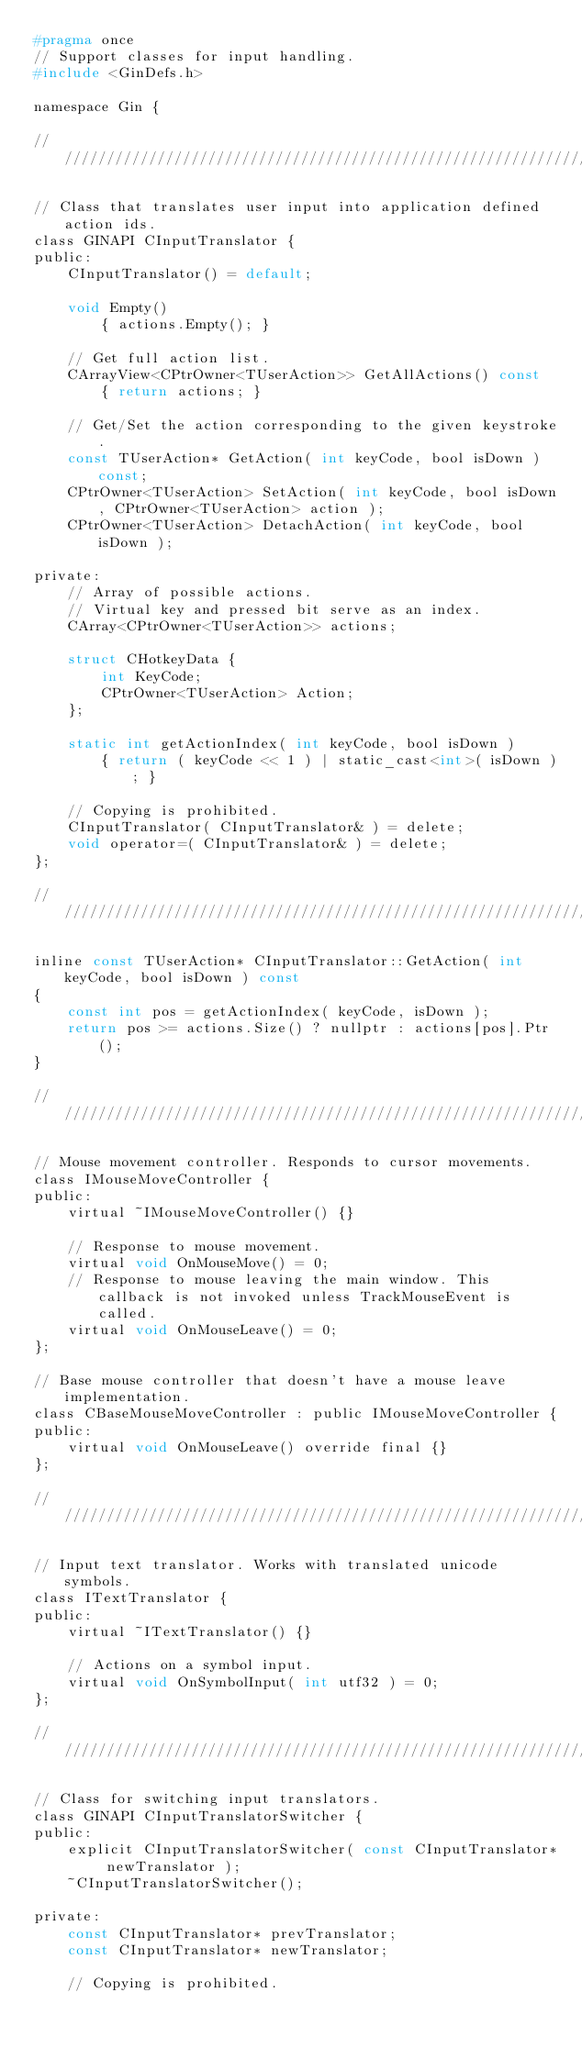Convert code to text. <code><loc_0><loc_0><loc_500><loc_500><_C_>#pragma once
// Support classes for input handling.
#include <GinDefs.h>

namespace Gin {

//////////////////////////////////////////////////////////////////////////

// Class that translates user input into application defined action ids.
class GINAPI CInputTranslator {
public:
	CInputTranslator() = default;

	void Empty()
		{ actions.Empty(); }
	
	// Get full action list.
	CArrayView<CPtrOwner<TUserAction>> GetAllActions() const
		{ return actions; }

	// Get/Set the action corresponding to the given keystroke.
	const TUserAction* GetAction( int keyCode, bool isDown ) const;
	CPtrOwner<TUserAction> SetAction( int keyCode, bool isDown, CPtrOwner<TUserAction> action );
	CPtrOwner<TUserAction> DetachAction( int keyCode, bool isDown );

private:
	// Array of possible actions.
	// Virtual key and pressed bit serve as an index.
	CArray<CPtrOwner<TUserAction>> actions;

	struct CHotkeyData {
		int KeyCode;
		CPtrOwner<TUserAction> Action;
	};

	static int getActionIndex( int keyCode, bool isDown )
		{ return ( keyCode << 1 ) | static_cast<int>( isDown ); }

	// Copying is prohibited.
	CInputTranslator( CInputTranslator& ) = delete;
	void operator=( CInputTranslator& ) = delete;
};

//////////////////////////////////////////////////////////////////////////

inline const TUserAction* CInputTranslator::GetAction( int keyCode, bool isDown ) const
{
	const int pos = getActionIndex( keyCode, isDown );
	return pos >= actions.Size() ? nullptr : actions[pos].Ptr();
}

//////////////////////////////////////////////////////////////////////////

// Mouse movement controller. Responds to cursor movements.
class IMouseMoveController {
public:
	virtual ~IMouseMoveController() {}

	// Response to mouse movement.
	virtual void OnMouseMove() = 0;
	// Response to mouse leaving the main window. This callback is not invoked unless TrackMouseEvent is called.
	virtual void OnMouseLeave() = 0;
};

// Base mouse controller that doesn't have a mouse leave implementation.
class CBaseMouseMoveController : public IMouseMoveController {
public:
	virtual void OnMouseLeave() override final {}
};

//////////////////////////////////////////////////////////////////////////

// Input text translator. Works with translated unicode symbols.
class ITextTranslator {
public:
	virtual ~ITextTranslator() {}

	// Actions on a symbol input.
	virtual void OnSymbolInput( int utf32 ) = 0;
};

//////////////////////////////////////////////////////////////////////////

// Class for switching input translators.
class GINAPI CInputTranslatorSwitcher {
public:
	explicit CInputTranslatorSwitcher( const CInputTranslator* newTranslator );
	~CInputTranslatorSwitcher();

private:
	const CInputTranslator* prevTranslator;
	const CInputTranslator* newTranslator;

	// Copying is prohibited.</code> 